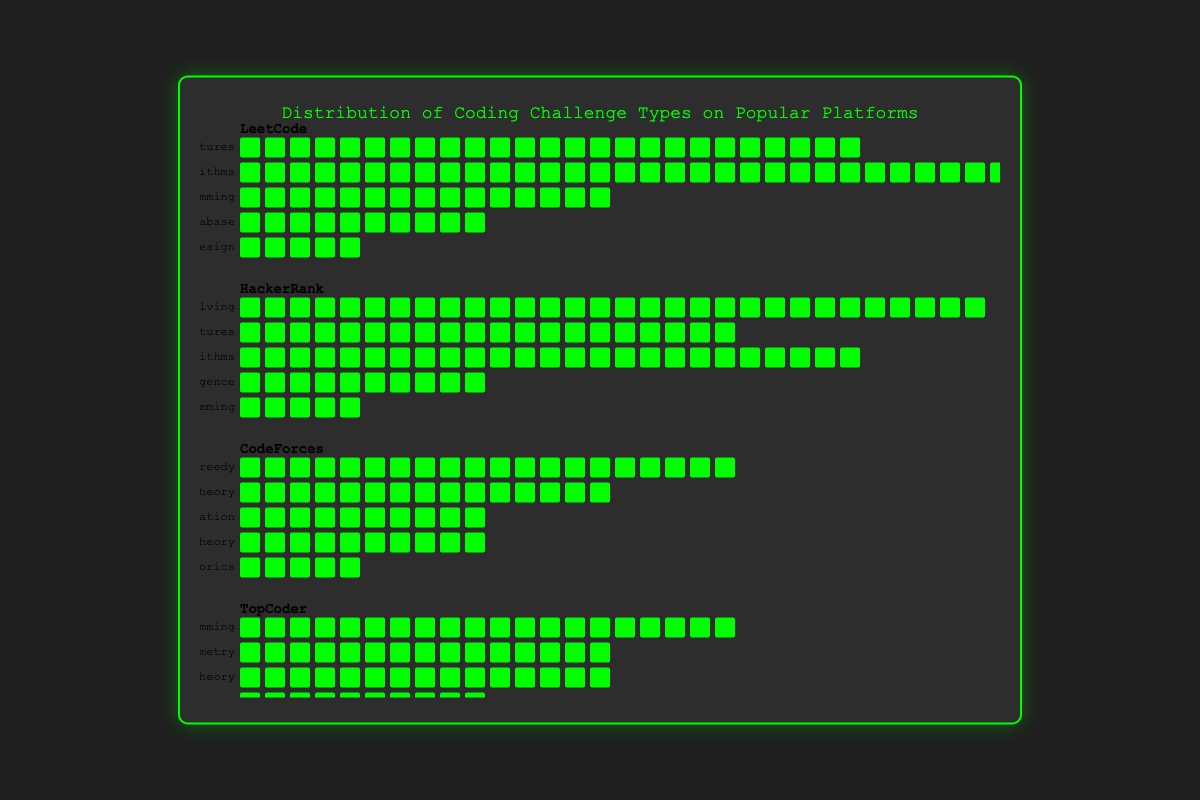What is the title of the chart? The title is displayed at the top of the figure, and it reads "Distribution of Coding Challenge Types on Popular Platforms". Thus, the title can be directly read.
Answer: Distribution of Coding Challenge Types on Popular Platforms Which platform has the most 'Algorithms' challenges? By visually observing the icons representing the 'Algorithms' challenges, we can see that LeetCode has the highest count indicated by the number of icons.
Answer: LeetCode How many 'Data Structures' challenges does LeetCode have? On the LeetCode row, there are 25 individual icons in the 'Data Structures' section. Each icon represents one challenge.
Answer: 25 Compare the number of 'Dynamic Programming' challenges on LeetCode and TopCoder. Which has more? By how much? LeetCode has 15 'Dynamic Programming' challenges, while TopCoder has 20. Subtracting the two, TopCoder has 5 more 'Dynamic Programming' challenges than LeetCode.
Answer: TopCoder by 5 What is the total number of 'Artificial Intelligence' and 'Functional Programming' challenges on HackerRank? HackerRank has 10 'Artificial Intelligence' challenges and 5 'Functional Programming' challenges. Adding these counts together, the total is 15.
Answer: 15 Which platform offers the fewest types of challenges, and how many types do they offer? By counting the different types of challenges for each platform, all platforms offer 5 types of challenges each. Therefore, no platform offers fewer types than others.
Answer: All platforms, 5 types each Among 'Graph Theory' challenges, which platform offers the most, and what is the count? By counting the 'Graph Theory' challenges, CodeForces and TopCoder both offer the most with 15 each.
Answer: CodeForces and TopCoder, 15 each What is the combined total of 'Database' and 'System Design' challenges on LeetCode? LeetCode has 10 'Database' challenges and 5 'System Design' challenges. Adding these two together gives a total of 15.
Answer: 15 How many more 'Problem Solving' challenges does HackerRank have compared to the total 'Graph Theory' challenges across all platforms? HackerRank has 30 'Problem Solving' challenges. Summing all 'Graph Theory' challenges: CodeForces has 15 and TopCoder has 15, totaling 30. The difference is 0.
Answer: 0 